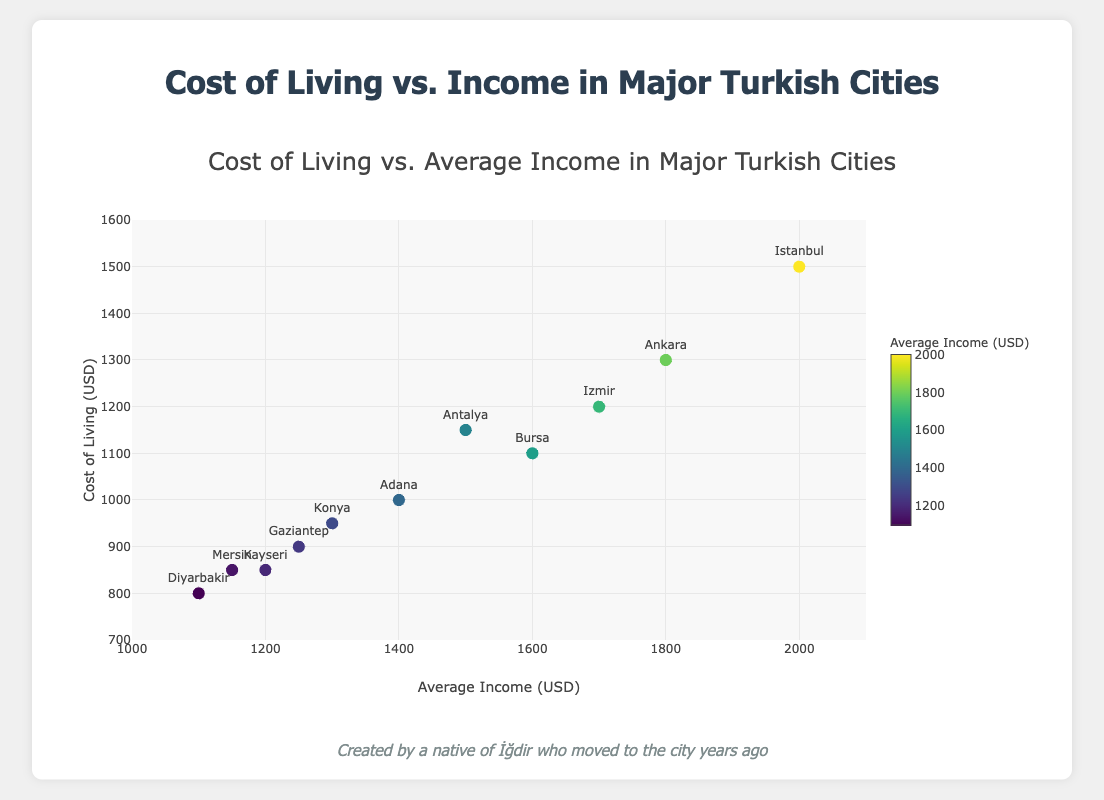What is the title of the figure? The title is displayed at the top center of the plot and provides a summary of what the figure represents. The plot title is: "Cost of Living vs. Average Income in Major Turkish Cities"
Answer: "Cost of Living vs. Average Income in Major Turkish Cities" Which city has the highest average income? Locate the point furthest to the right on the x-axis, which represents the highest average income. The city label next to this point is "Istanbul".
Answer: Istanbul What are the units used on the x-axis and y-axis? The labels on the x-axis and y-axis show the units. The x-axis is labeled "Average Income (USD)" and the y-axis is labeled "Cost of Living (USD)".
Answer: USD for both axes What is the range of average incomes represented in the plot? Check the range given on the x-axis. The minimum is 1000 and the maximum is 2100.
Answer: 1000 to 2100 USD How does the cost of living in Istanbul compare to Konya? Locate the points for Istanbul and Konya on the plot. Compare their y-axis values. Istanbul has a cost of living of 1500 USD, while Konya has a cost of living of 950 USD.
Answer: Istanbul's cost is higher Which city has the closest average income to its cost of living? Identify the city where the x (income) and y (cost of living) values are closest. For Istanbul, the difference is 500, for Ankara it’s 500, and so on. Antalya has an income of 1500 USD and a cost of living of 1150 USD, a difference of 350.
Answer: Antalya Calculate the average cost of living across all cities. Sum all cost of living values and divide by the number of cities. The sum is 1500+1300+1200+1100+1150+1000+950+900+850+800+850 = 13500. There are 11 cities, so 13500/11 = 1227.27 USD.
Answer: 1227.27 USD Which city has the lowest cost of living? Locate the point lowest on the y-axis. The label next to this point is "Diyarbakir" with a cost of living of 800 USD.
Answer: Diyarbakir Are there any cities with the same cost of living values? Compare the y-axis values across data points. Both Kayseri and Mersin have a cost of living of 850 USD.
Answer: Kayseri and Mersin 